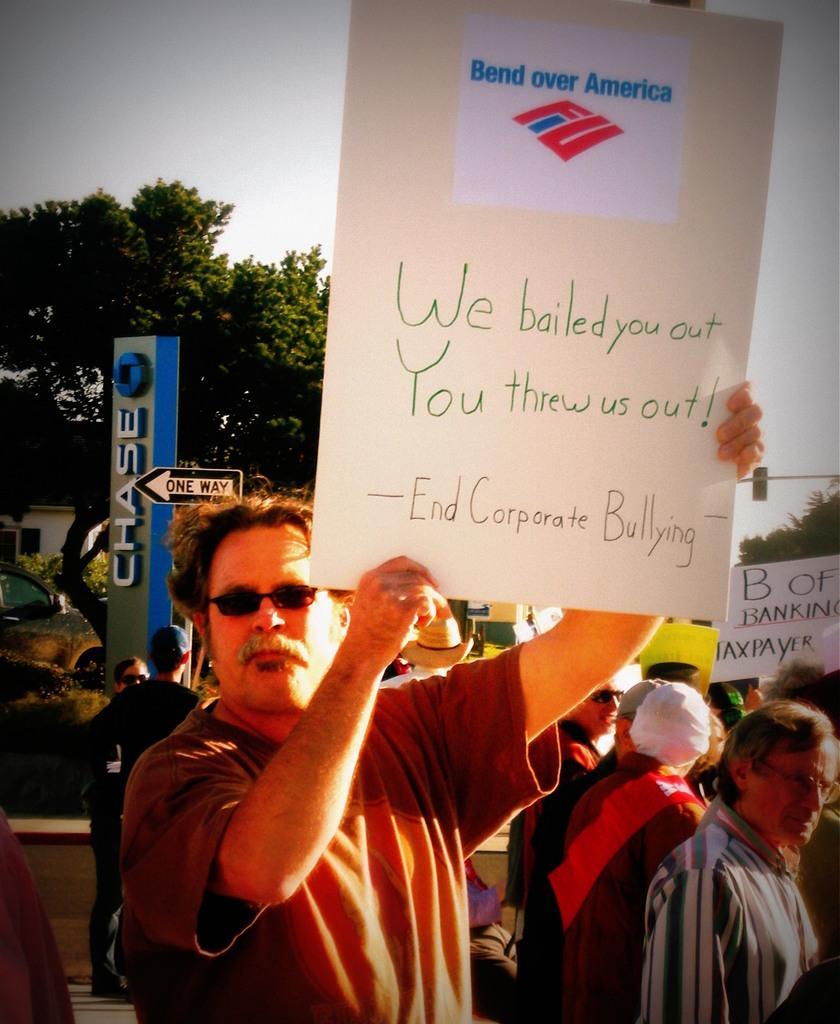Could you give a brief overview of what you see in this image? There are people standing and this man holding a board. In the background we can see boards,trees,car,house and sky. 